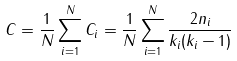Convert formula to latex. <formula><loc_0><loc_0><loc_500><loc_500>C = \frac { 1 } { N } \sum _ { i = 1 } ^ { N } C _ { i } = \frac { 1 } { N } \sum _ { i = 1 } ^ { N } \frac { 2 n _ { i } } { k _ { i } ( k _ { i } - 1 ) }</formula> 